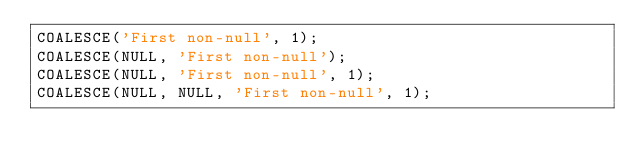<code> <loc_0><loc_0><loc_500><loc_500><_SQL_>COALESCE('First non-null', 1);
COALESCE(NULL, 'First non-null');
COALESCE(NULL, 'First non-null', 1);
COALESCE(NULL, NULL, 'First non-null', 1);</code> 